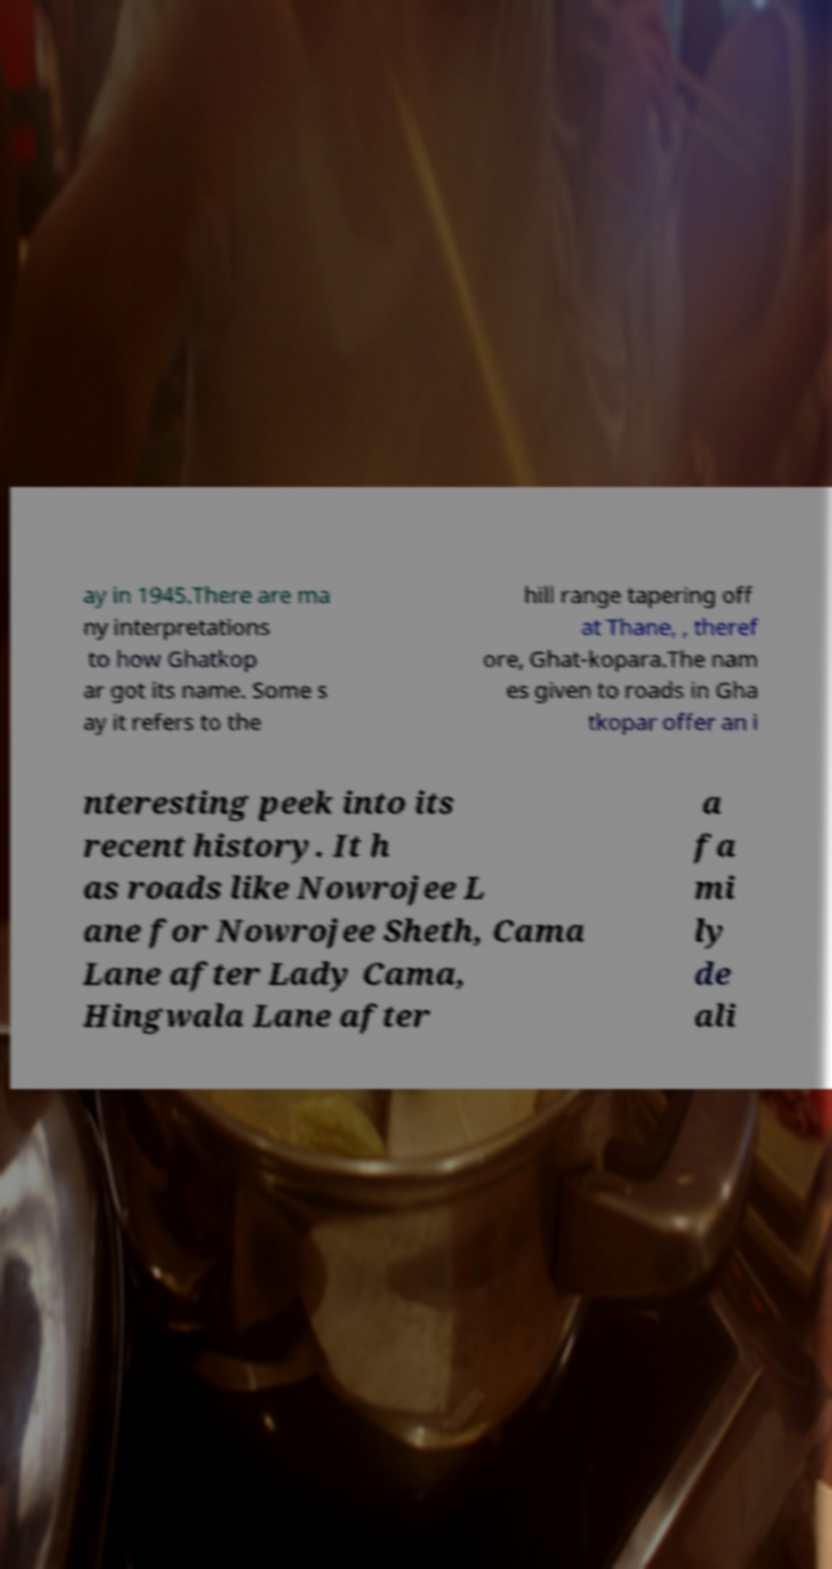What messages or text are displayed in this image? I need them in a readable, typed format. ay in 1945.There are ma ny interpretations to how Ghatkop ar got its name. Some s ay it refers to the hill range tapering off at Thane, , theref ore, Ghat-kopara.The nam es given to roads in Gha tkopar offer an i nteresting peek into its recent history. It h as roads like Nowrojee L ane for Nowrojee Sheth, Cama Lane after Lady Cama, Hingwala Lane after a fa mi ly de ali 